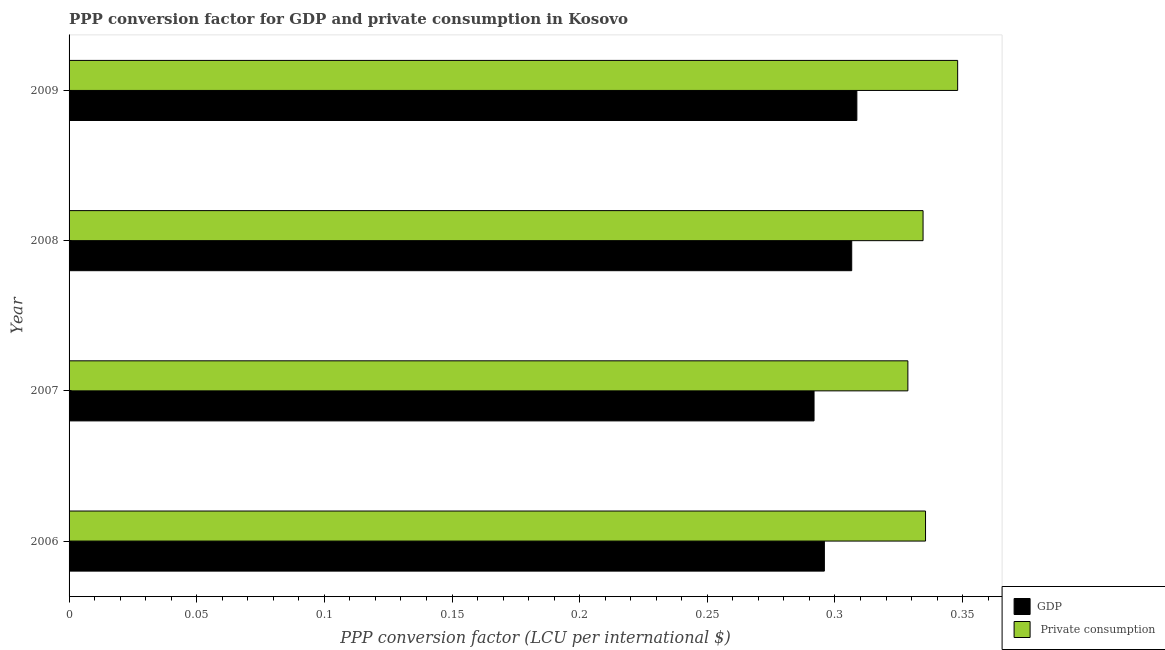How many bars are there on the 2nd tick from the bottom?
Offer a very short reply. 2. In how many cases, is the number of bars for a given year not equal to the number of legend labels?
Keep it short and to the point. 0. What is the ppp conversion factor for gdp in 2007?
Make the answer very short. 0.29. Across all years, what is the maximum ppp conversion factor for gdp?
Give a very brief answer. 0.31. Across all years, what is the minimum ppp conversion factor for private consumption?
Make the answer very short. 0.33. In which year was the ppp conversion factor for gdp maximum?
Ensure brevity in your answer.  2009. In which year was the ppp conversion factor for private consumption minimum?
Offer a terse response. 2007. What is the total ppp conversion factor for private consumption in the graph?
Offer a very short reply. 1.35. What is the difference between the ppp conversion factor for gdp in 2009 and the ppp conversion factor for private consumption in 2008?
Your response must be concise. -0.03. What is the average ppp conversion factor for gdp per year?
Give a very brief answer. 0.3. In the year 2009, what is the difference between the ppp conversion factor for private consumption and ppp conversion factor for gdp?
Ensure brevity in your answer.  0.04. Is the ppp conversion factor for gdp in 2006 less than that in 2008?
Your response must be concise. Yes. What is the difference between the highest and the second highest ppp conversion factor for gdp?
Provide a short and direct response. 0. What is the difference between the highest and the lowest ppp conversion factor for gdp?
Give a very brief answer. 0.02. In how many years, is the ppp conversion factor for gdp greater than the average ppp conversion factor for gdp taken over all years?
Provide a succinct answer. 2. Is the sum of the ppp conversion factor for gdp in 2007 and 2009 greater than the maximum ppp conversion factor for private consumption across all years?
Provide a short and direct response. Yes. What does the 2nd bar from the top in 2007 represents?
Offer a terse response. GDP. What does the 2nd bar from the bottom in 2008 represents?
Ensure brevity in your answer.   Private consumption. How many years are there in the graph?
Your response must be concise. 4. Does the graph contain any zero values?
Provide a short and direct response. No. Does the graph contain grids?
Your answer should be very brief. No. Where does the legend appear in the graph?
Your answer should be compact. Bottom right. How are the legend labels stacked?
Give a very brief answer. Vertical. What is the title of the graph?
Your answer should be very brief. PPP conversion factor for GDP and private consumption in Kosovo. Does "Under-5(female)" appear as one of the legend labels in the graph?
Ensure brevity in your answer.  No. What is the label or title of the X-axis?
Give a very brief answer. PPP conversion factor (LCU per international $). What is the PPP conversion factor (LCU per international $) of GDP in 2006?
Keep it short and to the point. 0.3. What is the PPP conversion factor (LCU per international $) of  Private consumption in 2006?
Make the answer very short. 0.34. What is the PPP conversion factor (LCU per international $) of GDP in 2007?
Your answer should be compact. 0.29. What is the PPP conversion factor (LCU per international $) in  Private consumption in 2007?
Your response must be concise. 0.33. What is the PPP conversion factor (LCU per international $) of GDP in 2008?
Your answer should be very brief. 0.31. What is the PPP conversion factor (LCU per international $) of  Private consumption in 2008?
Ensure brevity in your answer.  0.33. What is the PPP conversion factor (LCU per international $) in GDP in 2009?
Your response must be concise. 0.31. What is the PPP conversion factor (LCU per international $) in  Private consumption in 2009?
Give a very brief answer. 0.35. Across all years, what is the maximum PPP conversion factor (LCU per international $) in GDP?
Make the answer very short. 0.31. Across all years, what is the maximum PPP conversion factor (LCU per international $) of  Private consumption?
Give a very brief answer. 0.35. Across all years, what is the minimum PPP conversion factor (LCU per international $) of GDP?
Provide a succinct answer. 0.29. Across all years, what is the minimum PPP conversion factor (LCU per international $) in  Private consumption?
Make the answer very short. 0.33. What is the total PPP conversion factor (LCU per international $) of GDP in the graph?
Make the answer very short. 1.2. What is the total PPP conversion factor (LCU per international $) of  Private consumption in the graph?
Provide a succinct answer. 1.35. What is the difference between the PPP conversion factor (LCU per international $) of GDP in 2006 and that in 2007?
Ensure brevity in your answer.  0. What is the difference between the PPP conversion factor (LCU per international $) of  Private consumption in 2006 and that in 2007?
Provide a succinct answer. 0.01. What is the difference between the PPP conversion factor (LCU per international $) of GDP in 2006 and that in 2008?
Ensure brevity in your answer.  -0.01. What is the difference between the PPP conversion factor (LCU per international $) of  Private consumption in 2006 and that in 2008?
Your answer should be compact. 0. What is the difference between the PPP conversion factor (LCU per international $) of GDP in 2006 and that in 2009?
Provide a short and direct response. -0.01. What is the difference between the PPP conversion factor (LCU per international $) of  Private consumption in 2006 and that in 2009?
Your response must be concise. -0.01. What is the difference between the PPP conversion factor (LCU per international $) in GDP in 2007 and that in 2008?
Offer a terse response. -0.01. What is the difference between the PPP conversion factor (LCU per international $) in  Private consumption in 2007 and that in 2008?
Make the answer very short. -0.01. What is the difference between the PPP conversion factor (LCU per international $) in GDP in 2007 and that in 2009?
Provide a short and direct response. -0.02. What is the difference between the PPP conversion factor (LCU per international $) of  Private consumption in 2007 and that in 2009?
Your response must be concise. -0.02. What is the difference between the PPP conversion factor (LCU per international $) in GDP in 2008 and that in 2009?
Offer a terse response. -0. What is the difference between the PPP conversion factor (LCU per international $) of  Private consumption in 2008 and that in 2009?
Provide a short and direct response. -0.01. What is the difference between the PPP conversion factor (LCU per international $) in GDP in 2006 and the PPP conversion factor (LCU per international $) in  Private consumption in 2007?
Give a very brief answer. -0.03. What is the difference between the PPP conversion factor (LCU per international $) of GDP in 2006 and the PPP conversion factor (LCU per international $) of  Private consumption in 2008?
Keep it short and to the point. -0.04. What is the difference between the PPP conversion factor (LCU per international $) in GDP in 2006 and the PPP conversion factor (LCU per international $) in  Private consumption in 2009?
Ensure brevity in your answer.  -0.05. What is the difference between the PPP conversion factor (LCU per international $) of GDP in 2007 and the PPP conversion factor (LCU per international $) of  Private consumption in 2008?
Make the answer very short. -0.04. What is the difference between the PPP conversion factor (LCU per international $) of GDP in 2007 and the PPP conversion factor (LCU per international $) of  Private consumption in 2009?
Make the answer very short. -0.06. What is the difference between the PPP conversion factor (LCU per international $) in GDP in 2008 and the PPP conversion factor (LCU per international $) in  Private consumption in 2009?
Your answer should be very brief. -0.04. What is the average PPP conversion factor (LCU per international $) in GDP per year?
Your answer should be compact. 0.3. What is the average PPP conversion factor (LCU per international $) of  Private consumption per year?
Offer a very short reply. 0.34. In the year 2006, what is the difference between the PPP conversion factor (LCU per international $) of GDP and PPP conversion factor (LCU per international $) of  Private consumption?
Make the answer very short. -0.04. In the year 2007, what is the difference between the PPP conversion factor (LCU per international $) in GDP and PPP conversion factor (LCU per international $) in  Private consumption?
Ensure brevity in your answer.  -0.04. In the year 2008, what is the difference between the PPP conversion factor (LCU per international $) of GDP and PPP conversion factor (LCU per international $) of  Private consumption?
Make the answer very short. -0.03. In the year 2009, what is the difference between the PPP conversion factor (LCU per international $) of GDP and PPP conversion factor (LCU per international $) of  Private consumption?
Your answer should be compact. -0.04. What is the ratio of the PPP conversion factor (LCU per international $) in GDP in 2006 to that in 2007?
Offer a terse response. 1.01. What is the ratio of the PPP conversion factor (LCU per international $) of  Private consumption in 2006 to that in 2007?
Provide a short and direct response. 1.02. What is the ratio of the PPP conversion factor (LCU per international $) in GDP in 2006 to that in 2008?
Offer a terse response. 0.97. What is the ratio of the PPP conversion factor (LCU per international $) of  Private consumption in 2006 to that in 2008?
Provide a succinct answer. 1. What is the ratio of the PPP conversion factor (LCU per international $) in GDP in 2006 to that in 2009?
Your answer should be compact. 0.96. What is the ratio of the PPP conversion factor (LCU per international $) in  Private consumption in 2006 to that in 2009?
Give a very brief answer. 0.96. What is the ratio of the PPP conversion factor (LCU per international $) in GDP in 2007 to that in 2008?
Keep it short and to the point. 0.95. What is the ratio of the PPP conversion factor (LCU per international $) of  Private consumption in 2007 to that in 2008?
Provide a short and direct response. 0.98. What is the ratio of the PPP conversion factor (LCU per international $) in GDP in 2007 to that in 2009?
Provide a succinct answer. 0.95. What is the ratio of the PPP conversion factor (LCU per international $) of  Private consumption in 2007 to that in 2009?
Provide a short and direct response. 0.94. What is the ratio of the PPP conversion factor (LCU per international $) in  Private consumption in 2008 to that in 2009?
Offer a very short reply. 0.96. What is the difference between the highest and the second highest PPP conversion factor (LCU per international $) in GDP?
Offer a terse response. 0. What is the difference between the highest and the second highest PPP conversion factor (LCU per international $) of  Private consumption?
Your answer should be compact. 0.01. What is the difference between the highest and the lowest PPP conversion factor (LCU per international $) of GDP?
Your answer should be compact. 0.02. What is the difference between the highest and the lowest PPP conversion factor (LCU per international $) of  Private consumption?
Offer a terse response. 0.02. 